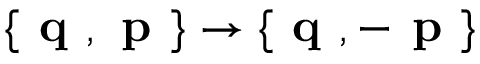<formula> <loc_0><loc_0><loc_500><loc_500>\{ q , p \} \rightarrow \{ q , - p \}</formula> 